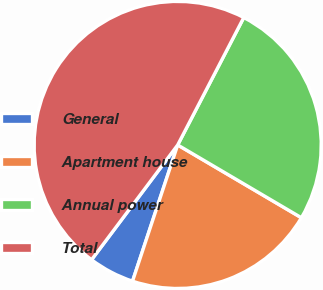Convert chart to OTSL. <chart><loc_0><loc_0><loc_500><loc_500><pie_chart><fcel>General<fcel>Apartment house<fcel>Annual power<fcel>Total<nl><fcel>5.15%<fcel>21.63%<fcel>25.85%<fcel>47.37%<nl></chart> 